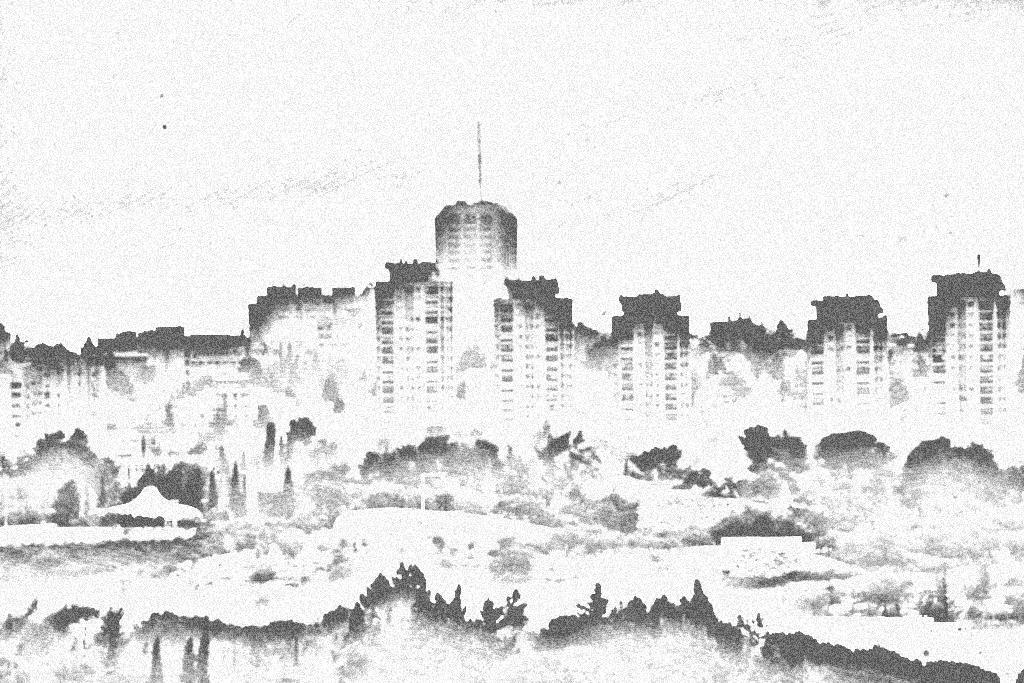What is the color scheme of the image? The image is black and white. What type of structures can be seen in the image? There are depictions of buildings in the image. What is visible at the top of the image? The sky is visible at the top of the image. Can you tell me how many snakes are slithering around the buildings in the image? There are no snakes present in the image; it features depictions of buildings in a black and white color scheme. 